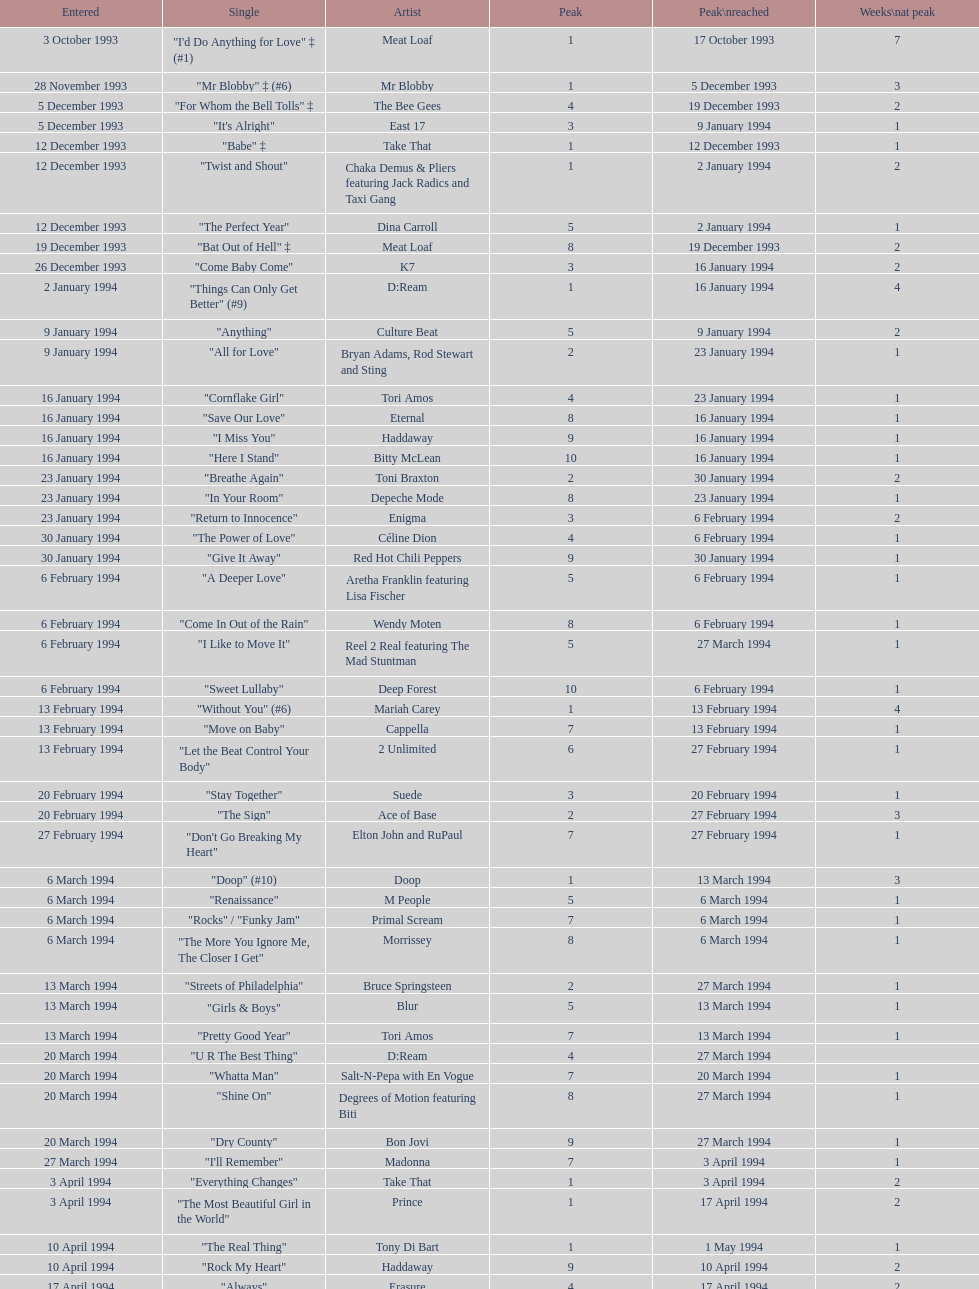Which single was the last one to be on the charts in 1993? "Come Baby Come". 